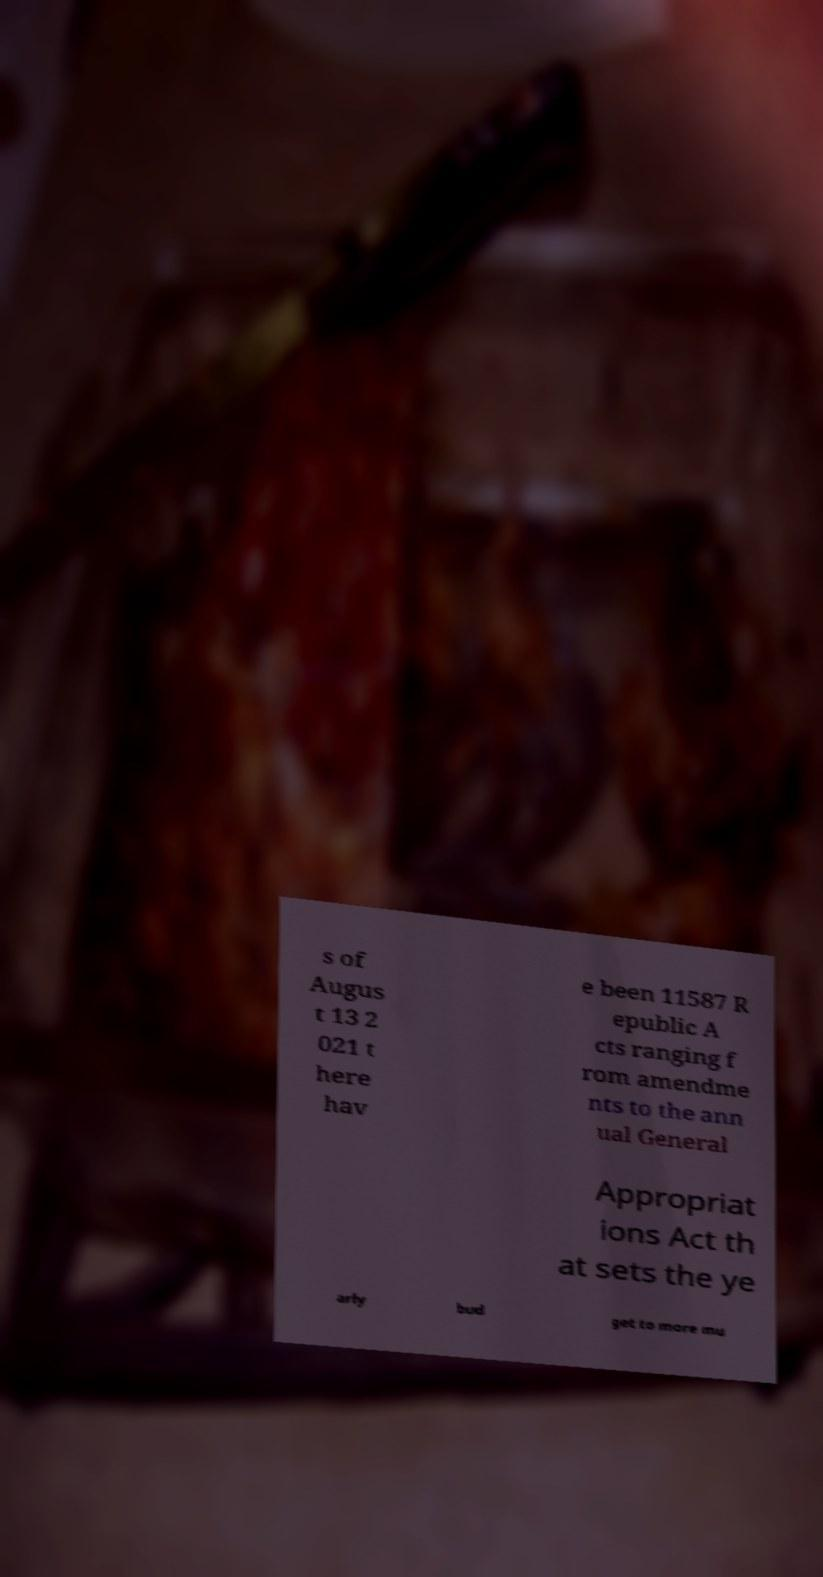Please read and relay the text visible in this image. What does it say? s of Augus t 13 2 021 t here hav e been 11587 R epublic A cts ranging f rom amendme nts to the ann ual General Appropriat ions Act th at sets the ye arly bud get to more mu 